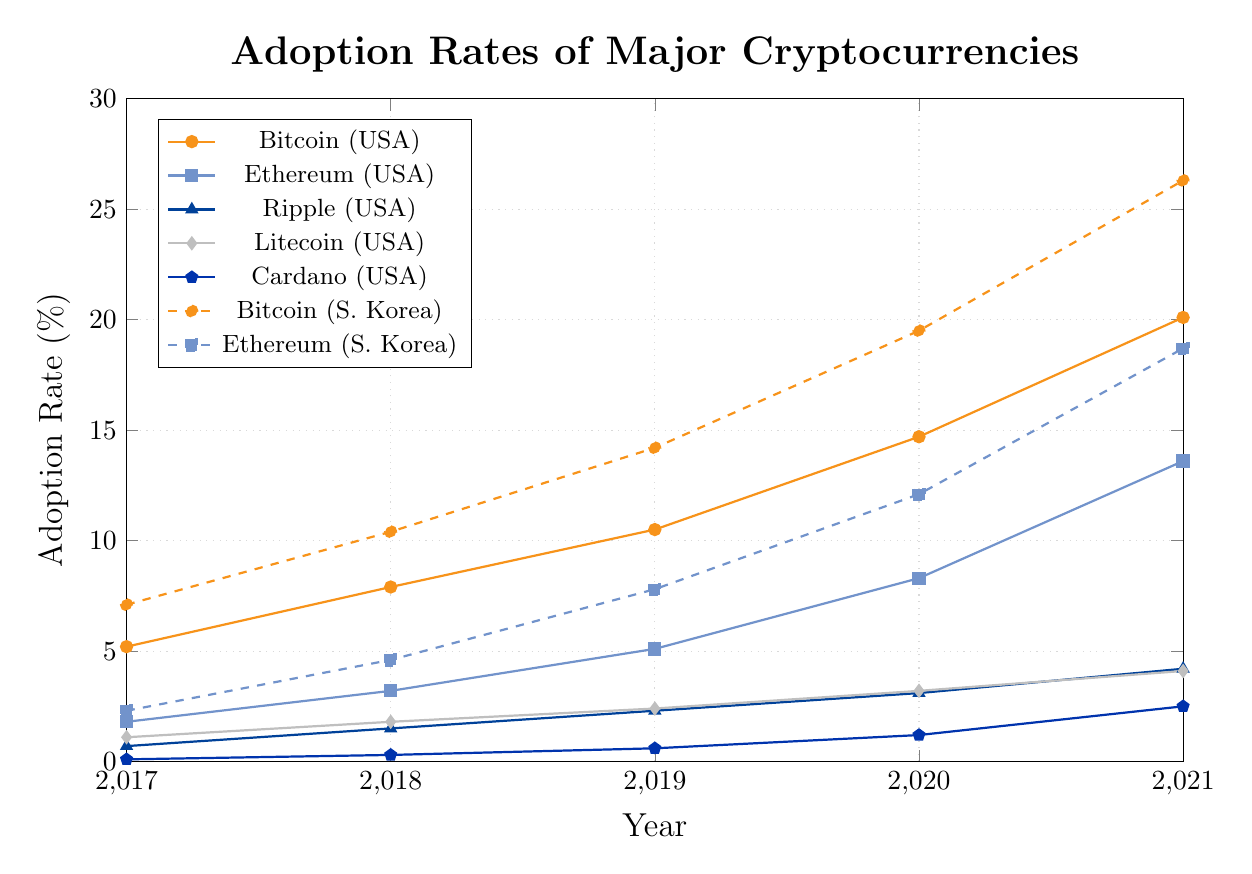Which cryptocurrency has the highest adoption rate in the United States in 2021? The chart shows various adoption rates of cryptocurrencies for different years and countries. By looking at the highest adoption rate in 2021 for the United States on the graph, Bitcoin stands out.
Answer: Bitcoin How did the adoption rate of Ethereum in South Korea change from 2017 to 2021? Reading the Ethereum adoption rate for South Korea from 2017 to 2021 on the graph: it started at 2.3% in 2017 and increased to 18.7% by 2021.
Answer: Increased Which country had a higher adoption rate of Bitcoin in 2020, the United States or Japan? By comparing the adoption rates for Bitcoin in 2020 between the United States and Japan on the graph: the rate is higher in the United States at 14.7% compared to Japan's 12.3%.
Answer: United States What is the difference in the adoption rate of Litecoin between 2018 and 2021 in Singapore? The adoption rate for Litecoin in Singapore in 2018 was 2.1%, and in 2021 it was 4.9%. The difference can be calculated as 4.9 - 2.1.
Answer: 2.8% Compare the growth of Bitcoin and Ethereum in the United States between 2017 and 2021. Which grew more? To determine which cryptocurrency grew more, subtract the 2017 values from the 2021 values for both Bitcoin and Ethereum in the United States: Bitcoin grew by 20.1 - 5.2 = 14.9% and Ethereum grew by 13.6 - 1.8 = 11.8%. Therefore, Bitcoin grew more.
Answer: Bitcoin If you average the adoption rates of Cardano from 2017 to 2021 in Germany, what would it be? The adoption rates for Cardano in Germany from 2017 to 2021 are 0.03, 0.15, 0.35, 0.8, and 1.7. Summing these values and dividing by 5 gives the average: (0.03 + 0.15 + 0.35 + 0.8 + 1.7) / 5 = 0.606.
Answer: 0.606% Which cryptocurrency showed the least growth in Japan from 2017 to 2021? The growth for each cryptocurrency in Japan from 2017 to 2021: Bitcoin (16.8 - 4.8 = 12.0), Ethereum (11.2 - 1.2 = 10.0), Ripple (4.5 - 0.9 = 3.6), Litecoin (3.5 - 0.8 = 2.7), and Cardano (2.1 - 0.05 = 2.05). Cardano showed the least growth.
Answer: Cardano 